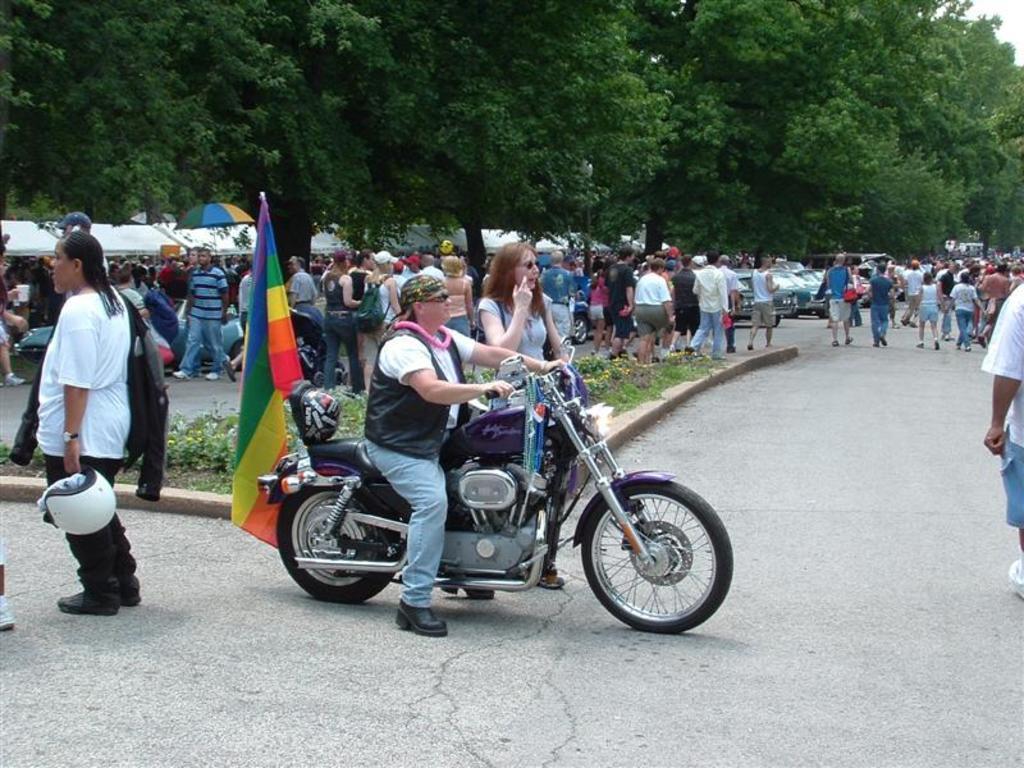In one or two sentences, can you explain what this image depicts? In this picture we can see a group of people walking on road and one is sitting on bike and here person holding helmet and in background we can see trees, umbrella, flags. 